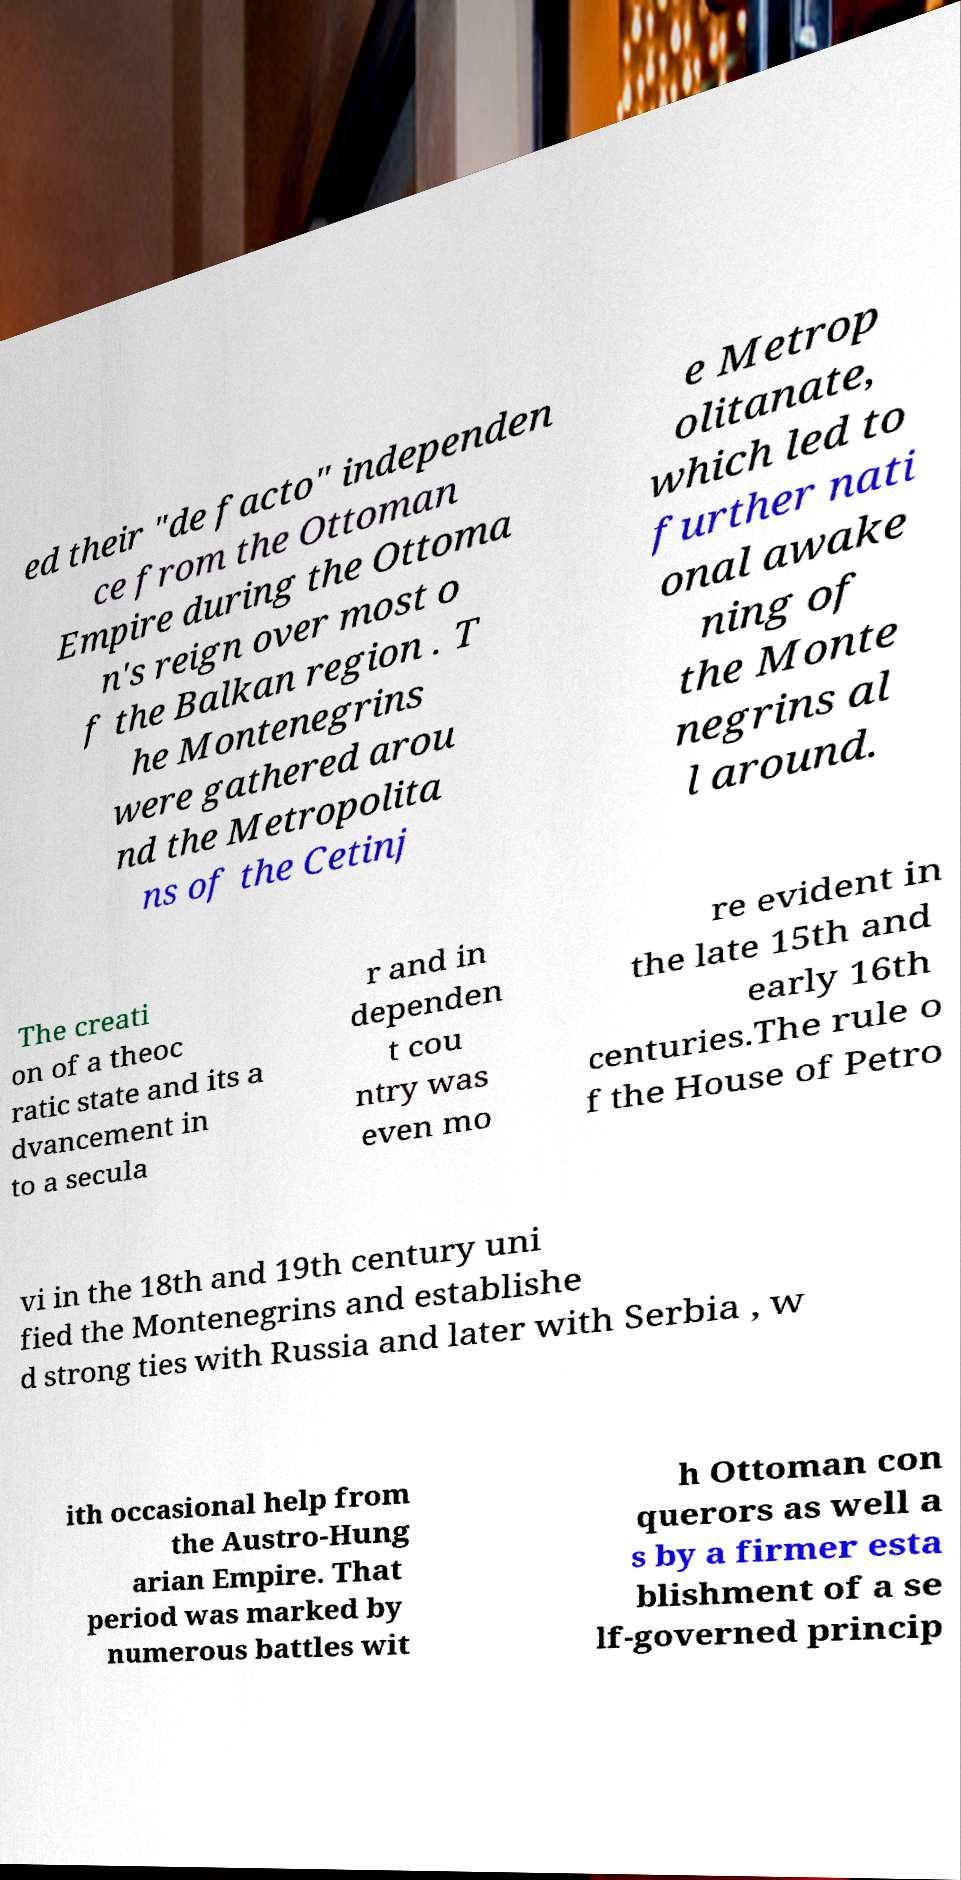What messages or text are displayed in this image? I need them in a readable, typed format. ed their "de facto" independen ce from the Ottoman Empire during the Ottoma n's reign over most o f the Balkan region . T he Montenegrins were gathered arou nd the Metropolita ns of the Cetinj e Metrop olitanate, which led to further nati onal awake ning of the Monte negrins al l around. The creati on of a theoc ratic state and its a dvancement in to a secula r and in dependen t cou ntry was even mo re evident in the late 15th and early 16th centuries.The rule o f the House of Petro vi in the 18th and 19th century uni fied the Montenegrins and establishe d strong ties with Russia and later with Serbia , w ith occasional help from the Austro-Hung arian Empire. That period was marked by numerous battles wit h Ottoman con querors as well a s by a firmer esta blishment of a se lf-governed princip 